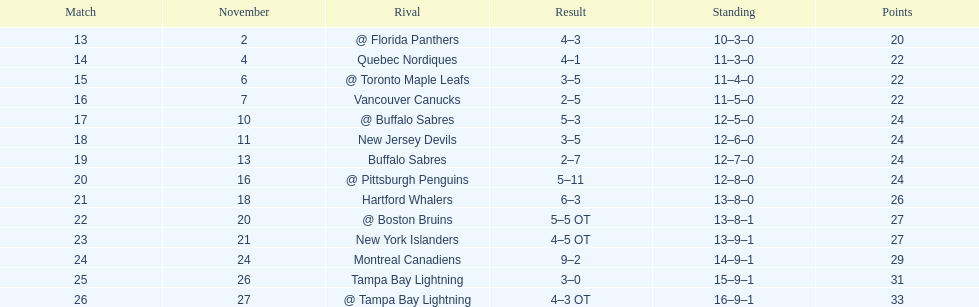What other team had the closest amount of wins? New York Islanders. 